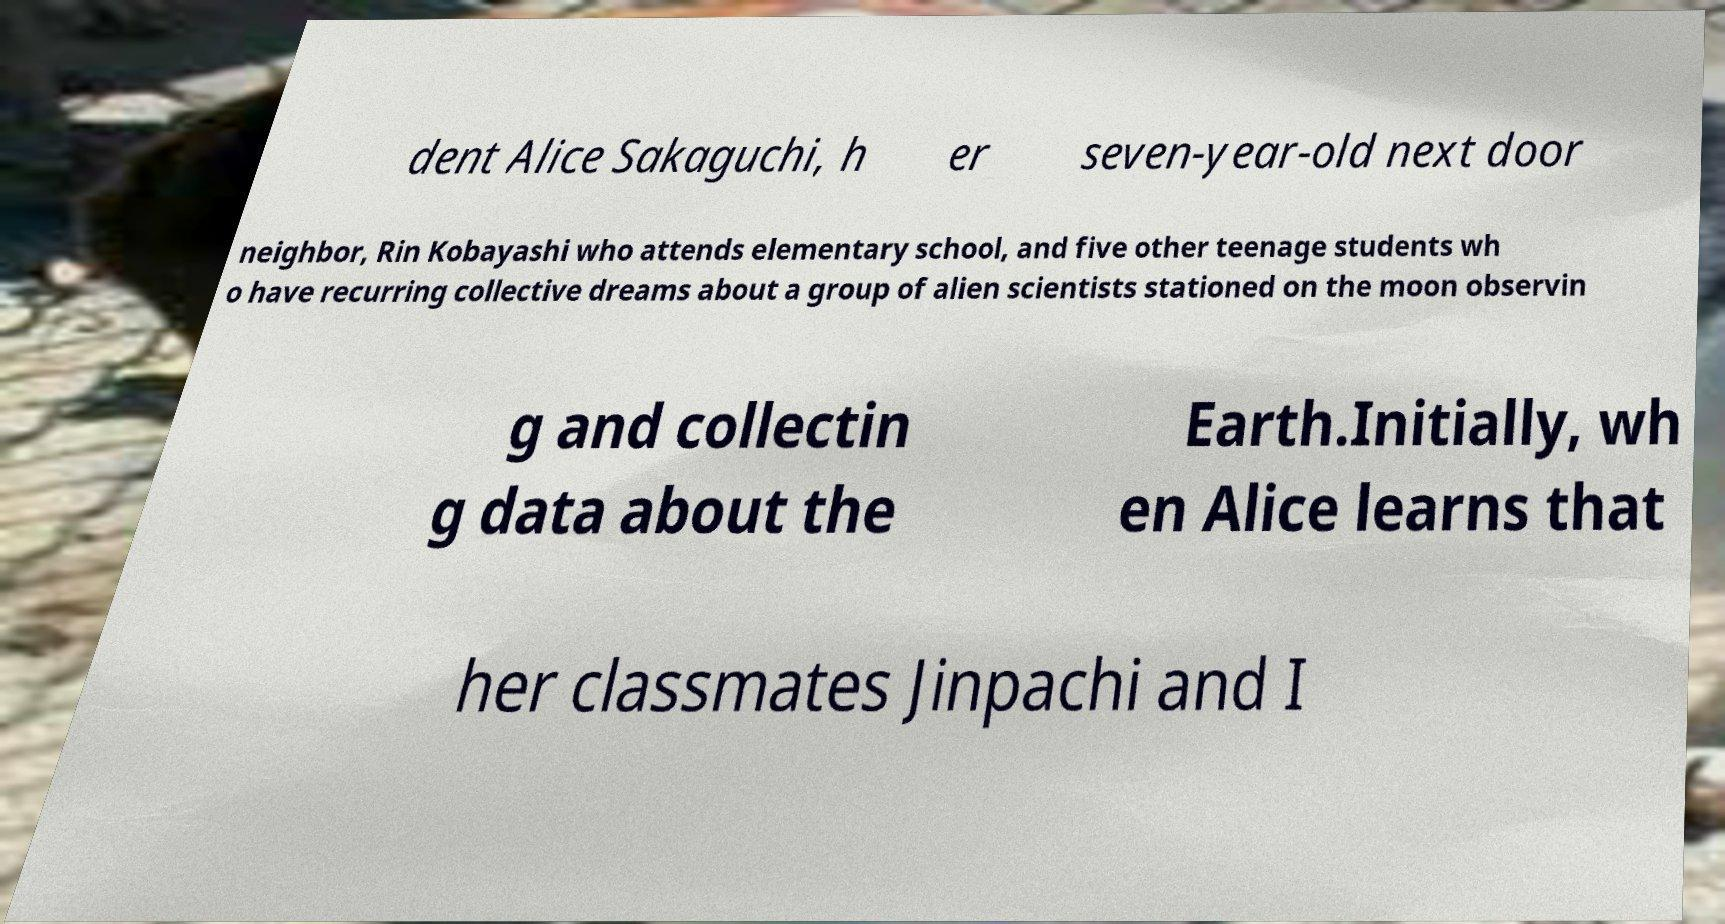I need the written content from this picture converted into text. Can you do that? dent Alice Sakaguchi, h er seven-year-old next door neighbor, Rin Kobayashi who attends elementary school, and five other teenage students wh o have recurring collective dreams about a group of alien scientists stationed on the moon observin g and collectin g data about the Earth.Initially, wh en Alice learns that her classmates Jinpachi and I 